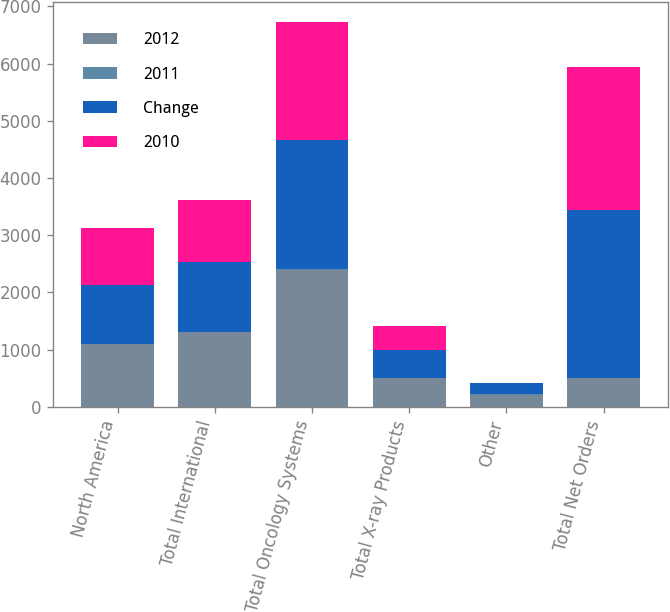Convert chart to OTSL. <chart><loc_0><loc_0><loc_500><loc_500><stacked_bar_chart><ecel><fcel>North America<fcel>Total International<fcel>Total Oncology Systems<fcel>Total X-ray Products<fcel>Other<fcel>Total Net Orders<nl><fcel>2012<fcel>1091<fcel>1309<fcel>2400<fcel>506<fcel>216<fcel>506<nl><fcel>2011<fcel>5<fcel>8<fcel>7<fcel>5<fcel>7<fcel>6<nl><fcel>Change<fcel>1038<fcel>1211<fcel>2249<fcel>483<fcel>201<fcel>2933<nl><fcel>2010<fcel>985<fcel>1091<fcel>2076<fcel>419<fcel>0<fcel>2495<nl></chart> 